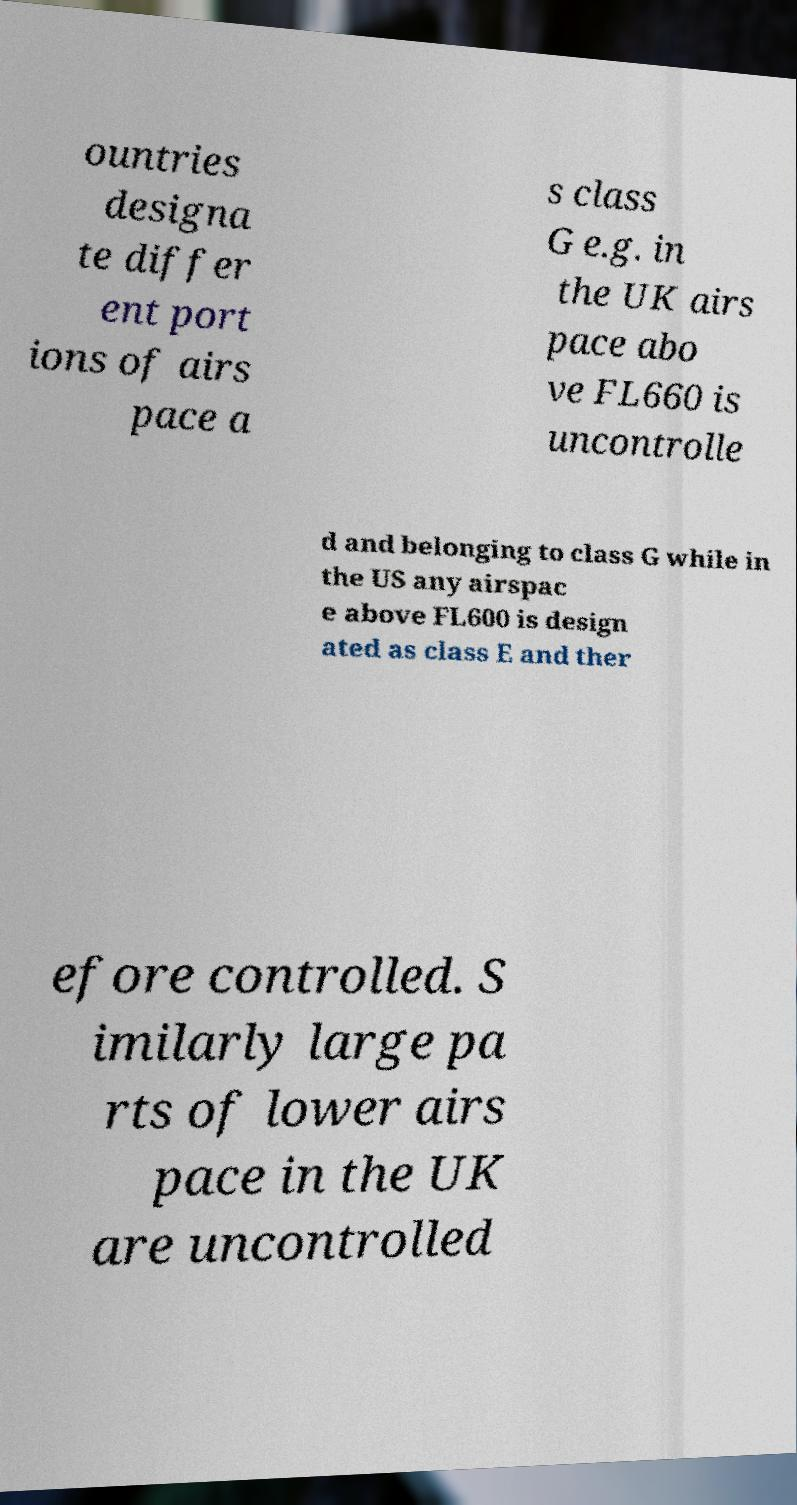I need the written content from this picture converted into text. Can you do that? ountries designa te differ ent port ions of airs pace a s class G e.g. in the UK airs pace abo ve FL660 is uncontrolle d and belonging to class G while in the US any airspac e above FL600 is design ated as class E and ther efore controlled. S imilarly large pa rts of lower airs pace in the UK are uncontrolled 